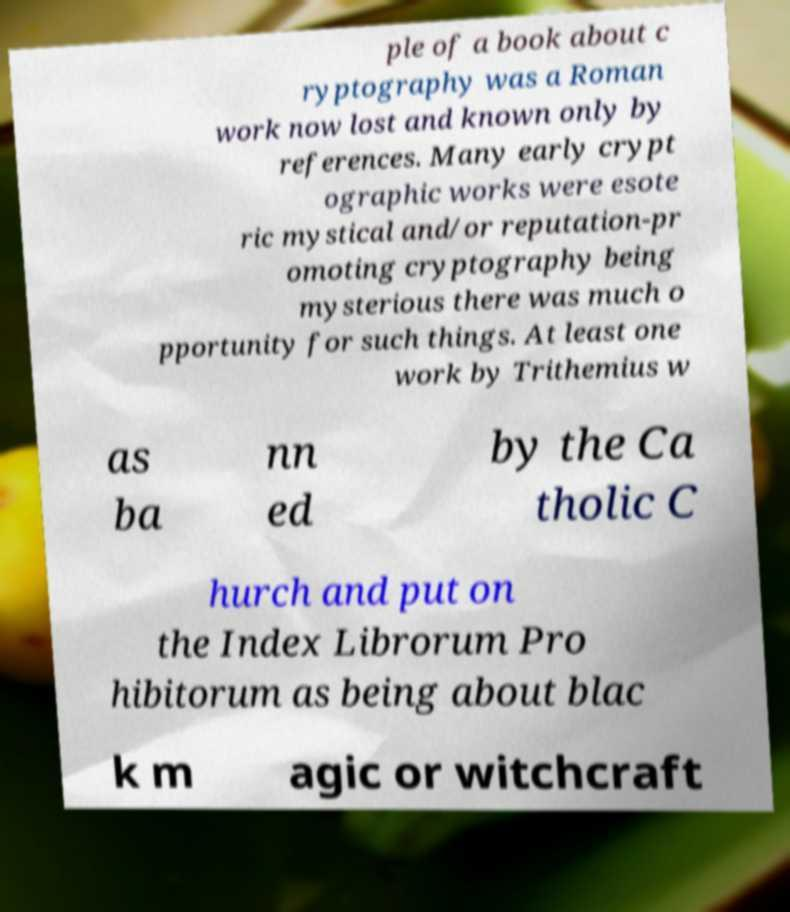Please identify and transcribe the text found in this image. ple of a book about c ryptography was a Roman work now lost and known only by references. Many early crypt ographic works were esote ric mystical and/or reputation-pr omoting cryptography being mysterious there was much o pportunity for such things. At least one work by Trithemius w as ba nn ed by the Ca tholic C hurch and put on the Index Librorum Pro hibitorum as being about blac k m agic or witchcraft 